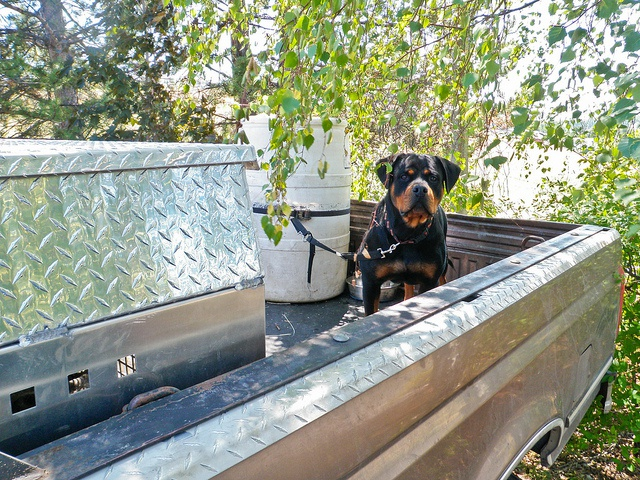Describe the objects in this image and their specific colors. I can see truck in gray, darkgray, lightgray, and lightblue tones and dog in gray, black, and maroon tones in this image. 